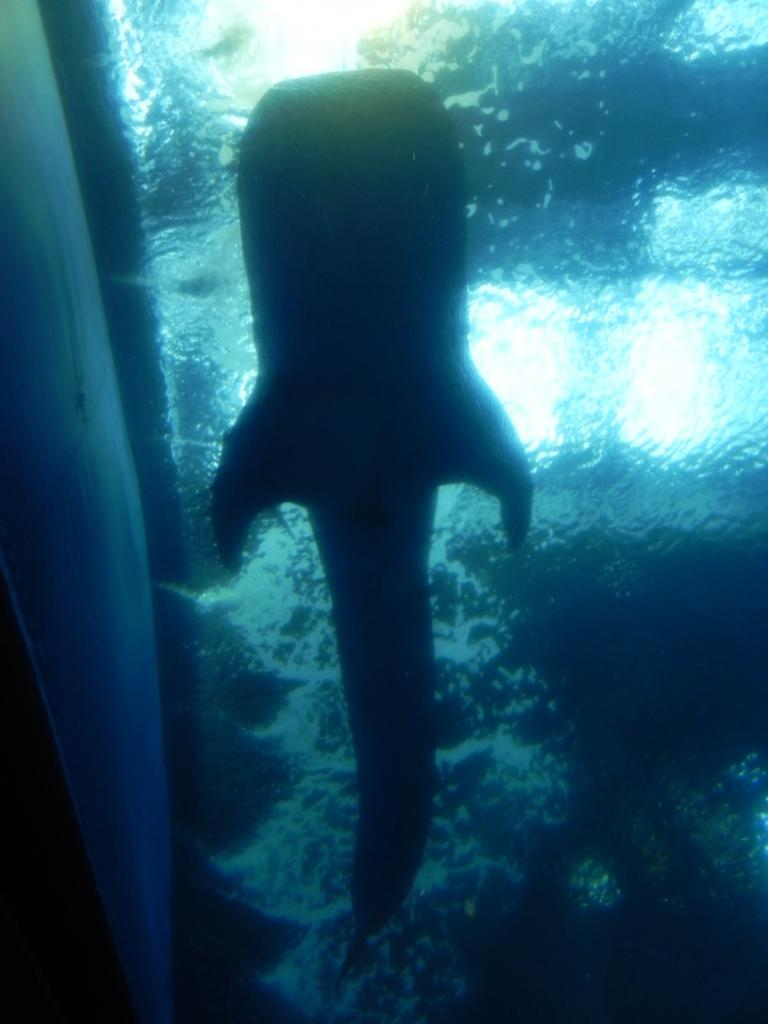What is the main subject of the image? There is a fish in the image. Where is the fish located? The fish is in water. What is the water contained within? The water is inside a glass. How is the glass positioned in the image? The glass is in the foreground of the image. What type of shirt is the fish wearing in the image? There is no shirt present in the image, as fish do not wear clothing. 